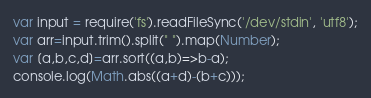Convert code to text. <code><loc_0><loc_0><loc_500><loc_500><_JavaScript_>var input = require('fs').readFileSync('/dev/stdin', 'utf8');
var arr=input.trim().split(" ").map(Number);
var [a,b,c,d]=arr.sort((a,b)=>b-a);
console.log(Math.abs((a+d)-(b+c)));
</code> 